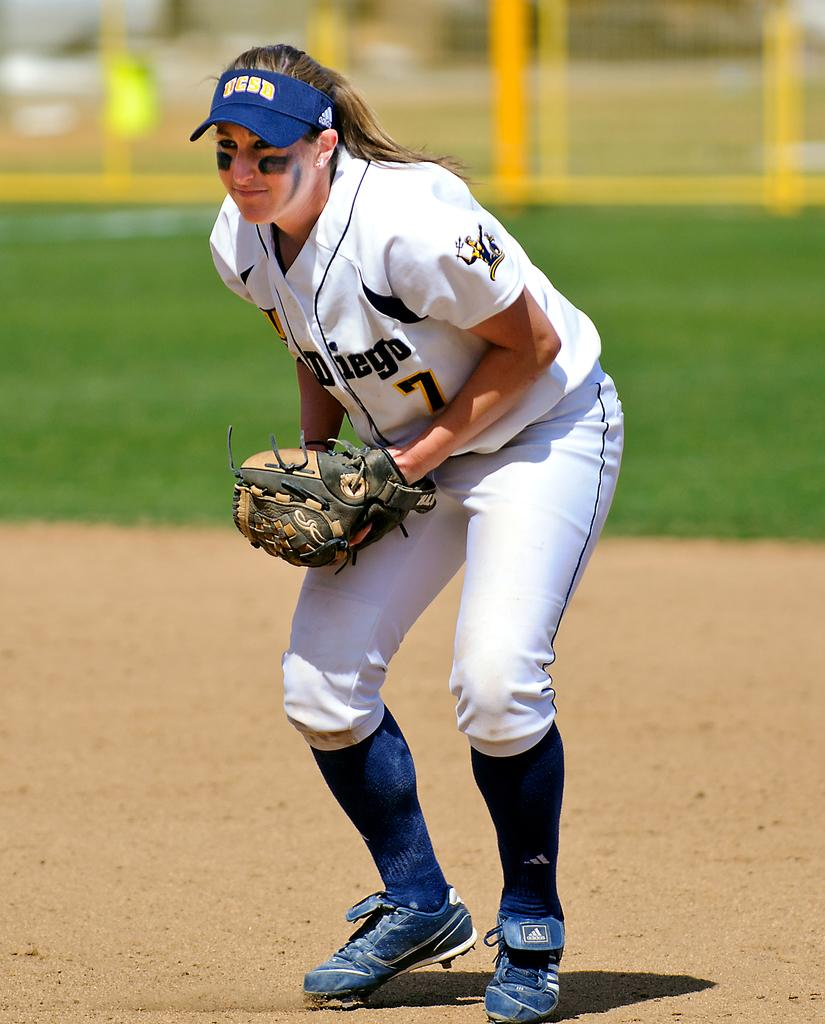<image>
Relay a brief, clear account of the picture shown. A UCSD softball player wearing number 7 in a game. 